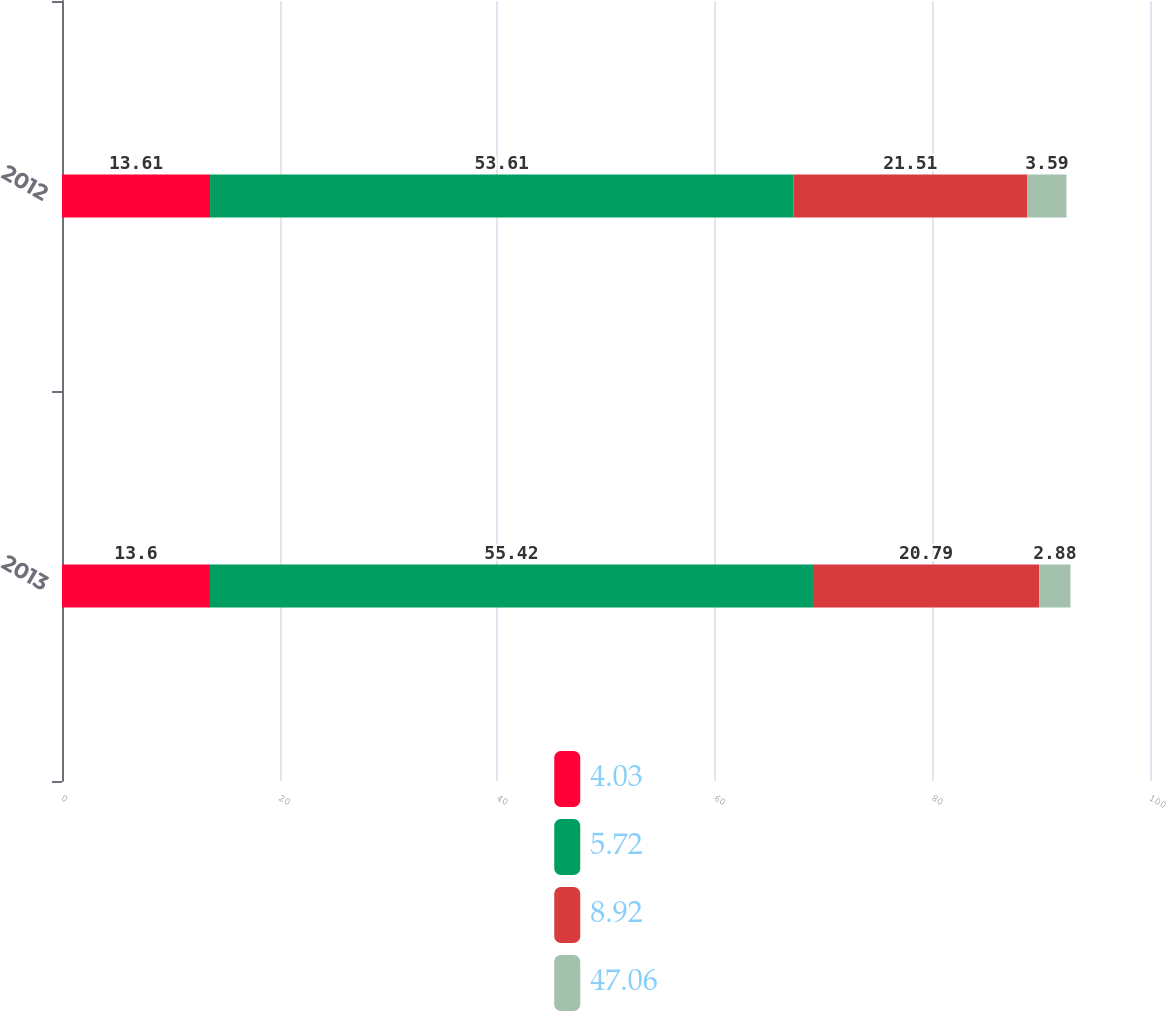Convert chart to OTSL. <chart><loc_0><loc_0><loc_500><loc_500><stacked_bar_chart><ecel><fcel>2013<fcel>2012<nl><fcel>4.03<fcel>13.6<fcel>13.61<nl><fcel>5.72<fcel>55.42<fcel>53.61<nl><fcel>8.92<fcel>20.79<fcel>21.51<nl><fcel>47.06<fcel>2.88<fcel>3.59<nl></chart> 